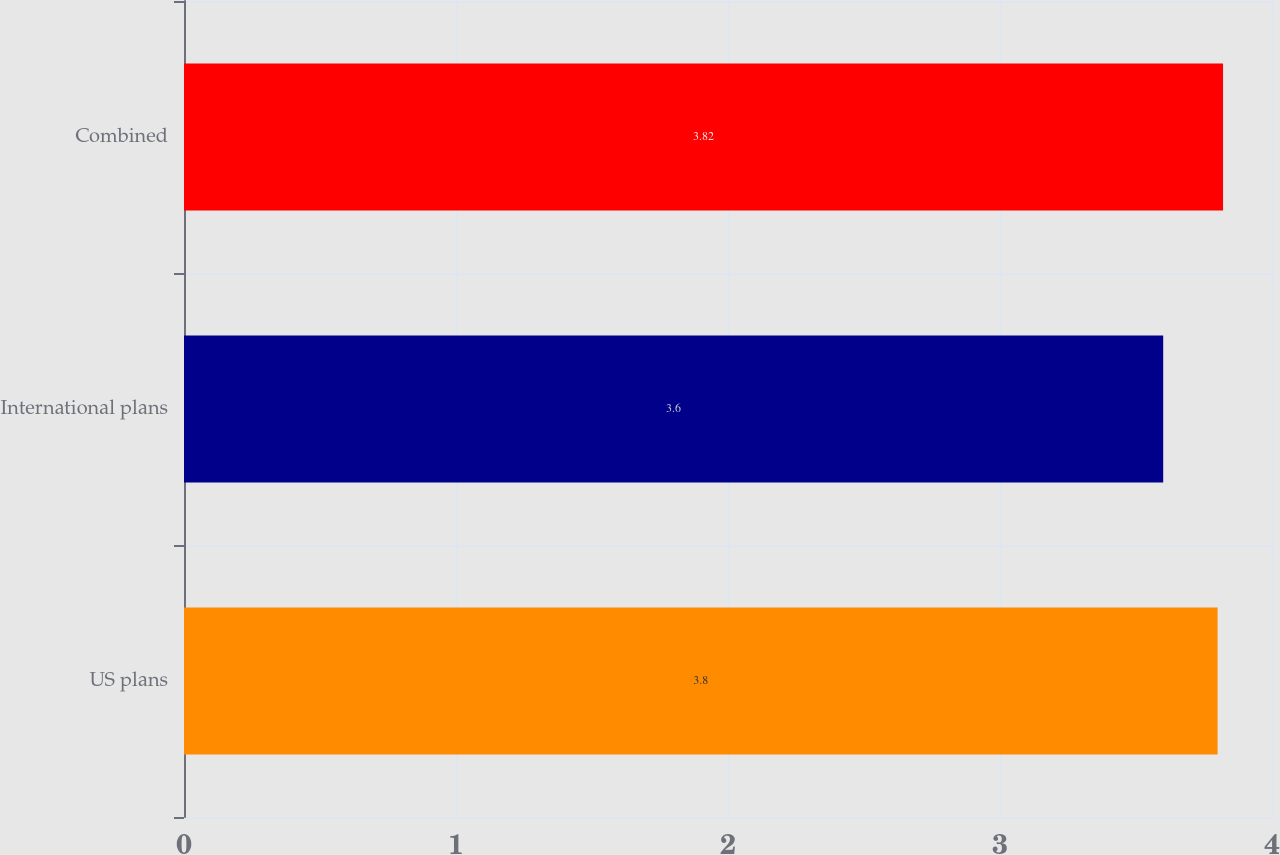<chart> <loc_0><loc_0><loc_500><loc_500><bar_chart><fcel>US plans<fcel>International plans<fcel>Combined<nl><fcel>3.8<fcel>3.6<fcel>3.82<nl></chart> 